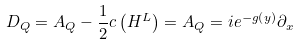<formula> <loc_0><loc_0><loc_500><loc_500>D _ { Q } = A _ { Q } - \frac { 1 } { 2 } c \left ( H ^ { L } \right ) = A _ { Q } = i e ^ { - g \left ( y \right ) } \partial _ { x }</formula> 